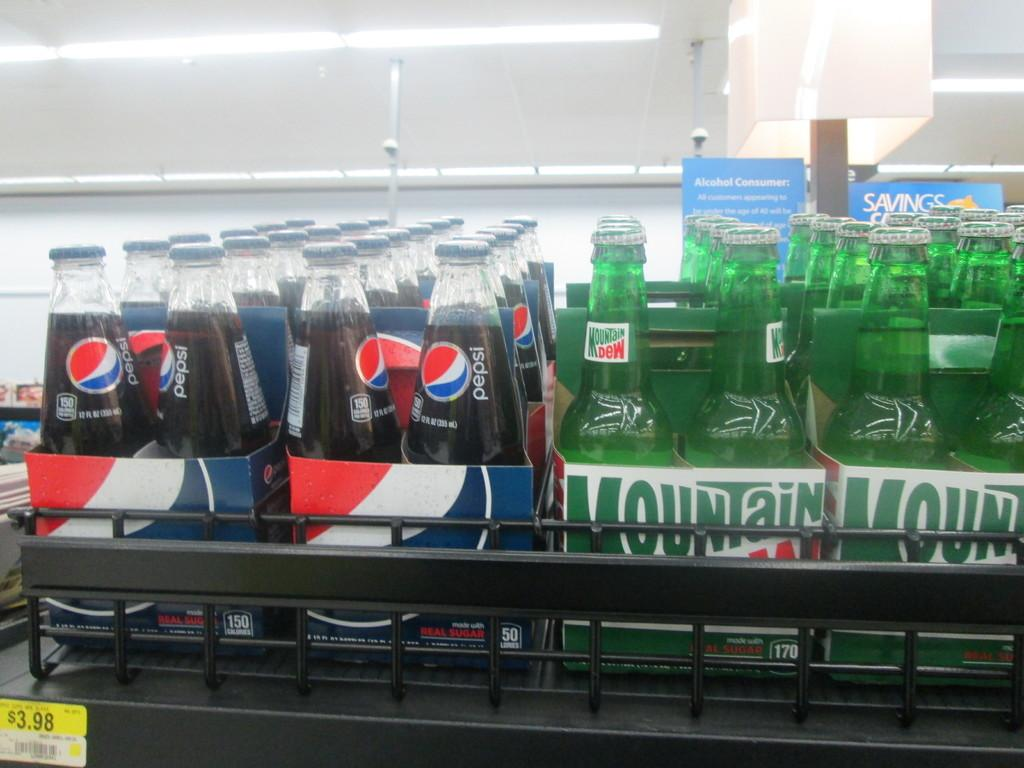<image>
Give a short and clear explanation of the subsequent image. Packs of Pepsi and Mountain Dew are side by side on a shelf. 